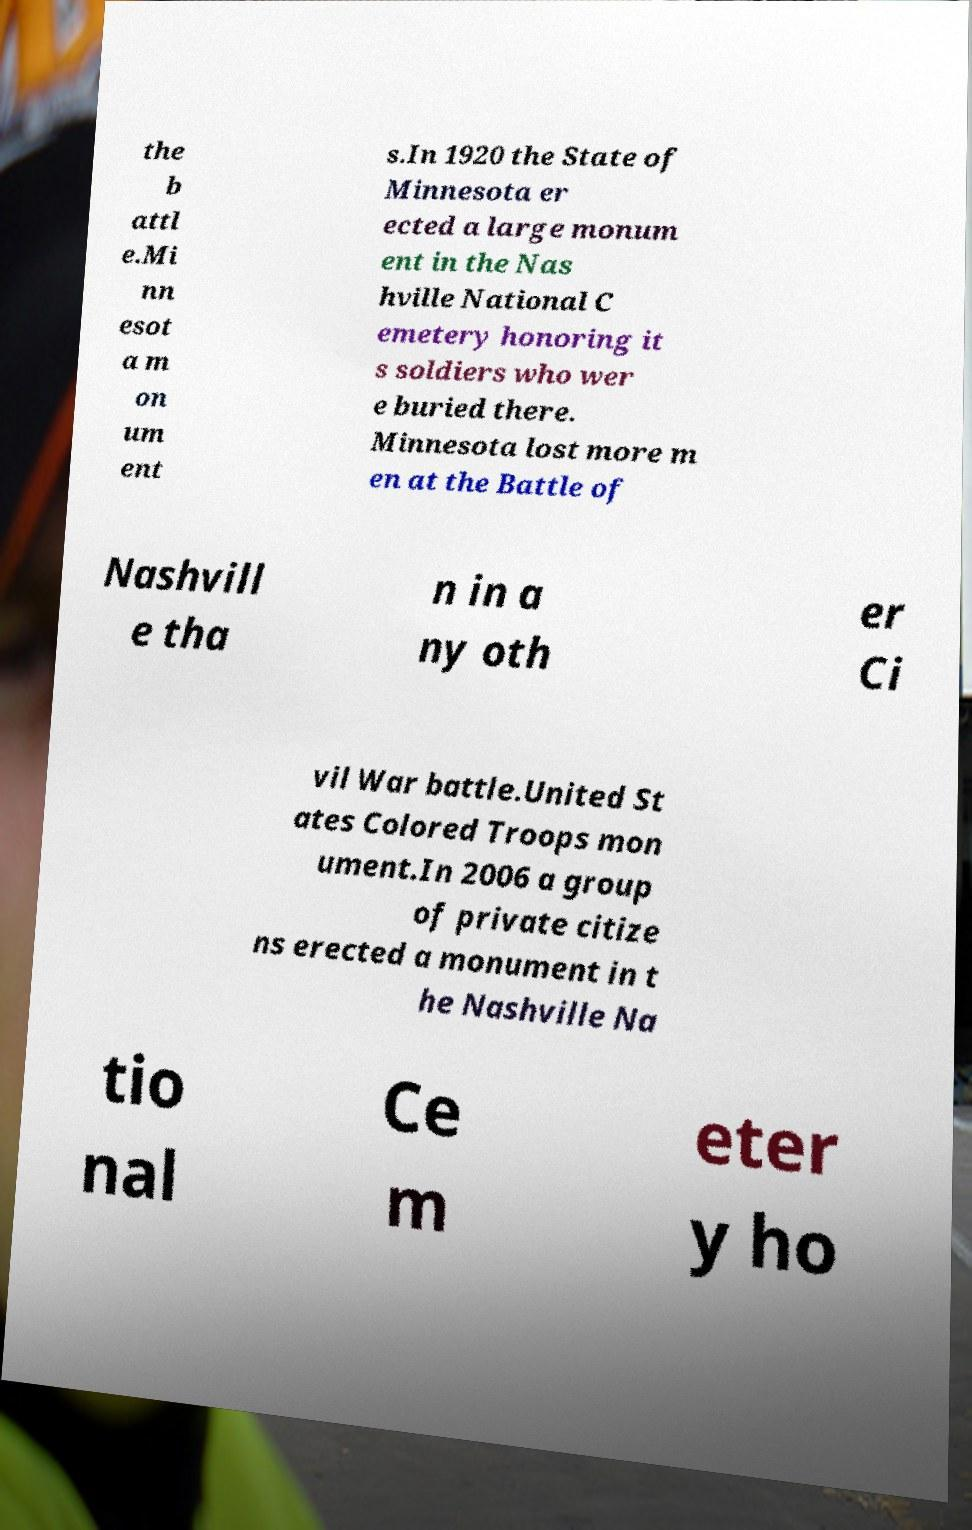There's text embedded in this image that I need extracted. Can you transcribe it verbatim? the b attl e.Mi nn esot a m on um ent s.In 1920 the State of Minnesota er ected a large monum ent in the Nas hville National C emetery honoring it s soldiers who wer e buried there. Minnesota lost more m en at the Battle of Nashvill e tha n in a ny oth er Ci vil War battle.United St ates Colored Troops mon ument.In 2006 a group of private citize ns erected a monument in t he Nashville Na tio nal Ce m eter y ho 